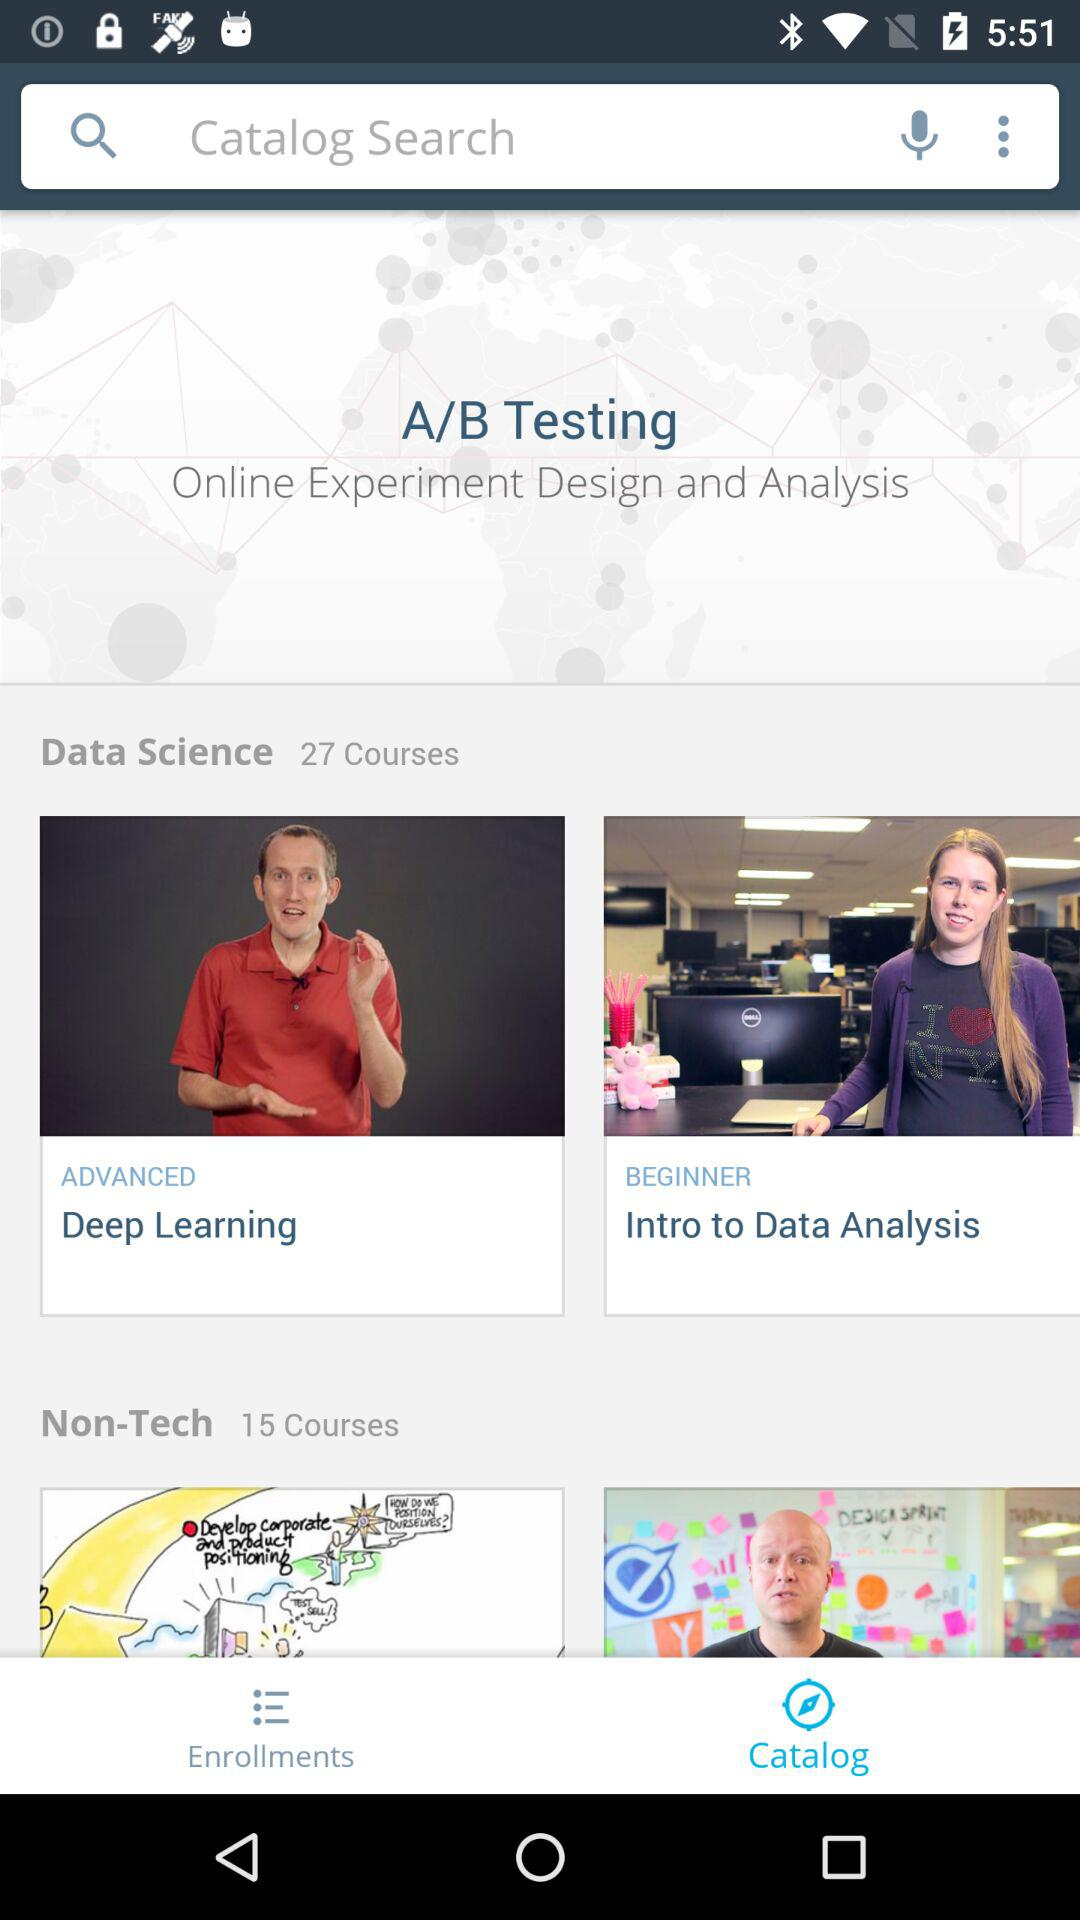What is the level of the course "Deep Learning"? The level is "ADVANCED". 